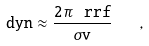Convert formula to latex. <formula><loc_0><loc_0><loc_500><loc_500>\tt d y n \approx \frac { 2 \pi \, \ r r f } { \sigma v } \quad ,</formula> 